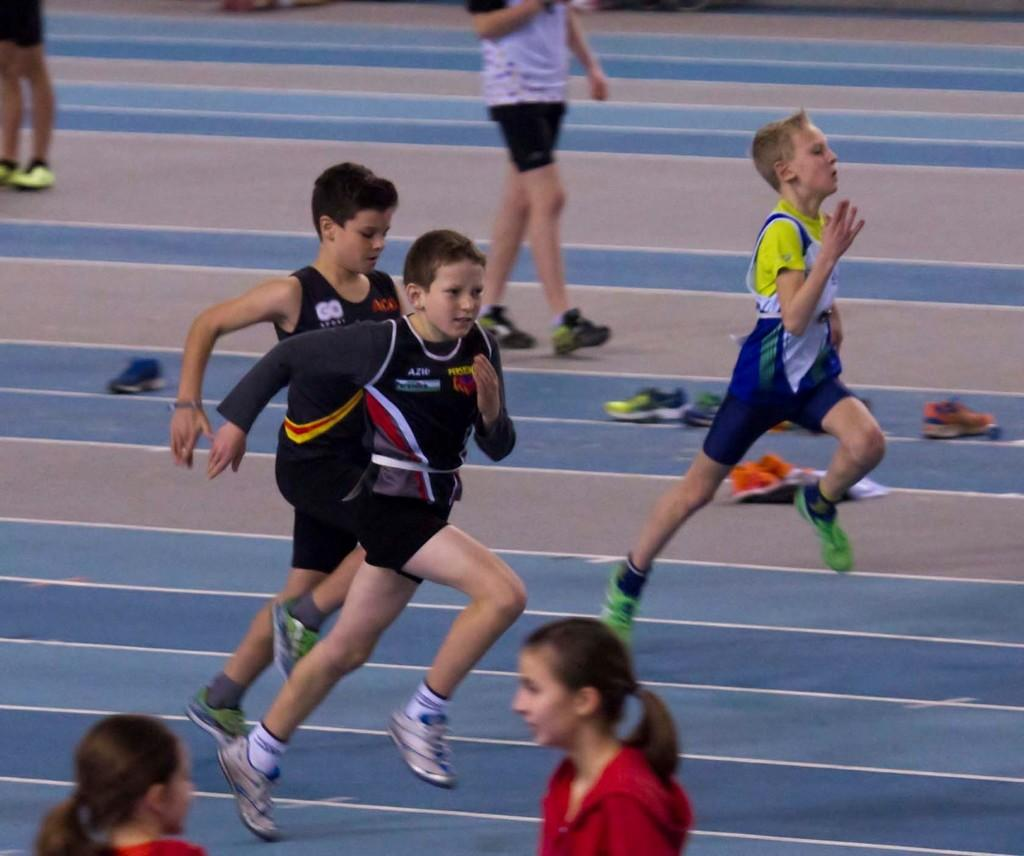What are the children doing in the image? There are children running and walking in the image. Where are the children located in the image? The children are on a path in the image. What can be seen in the middle of the image? There are shoes in the middle of the image. What type of songs can be heard being sung by the children in the image? There is no indication in the image that the children are singing songs, so it cannot be determined from the picture. 